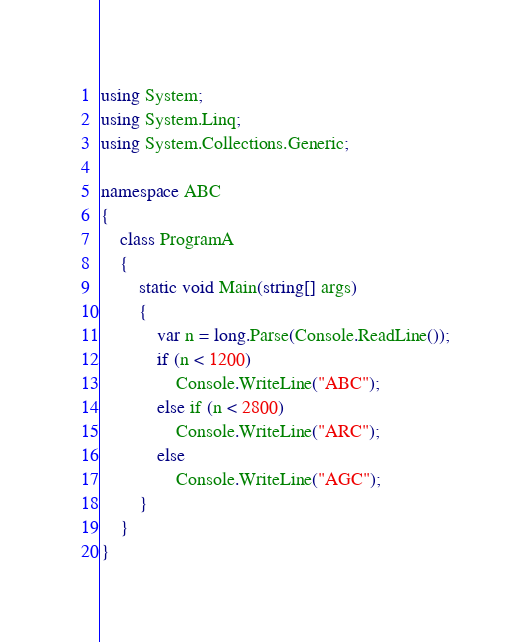<code> <loc_0><loc_0><loc_500><loc_500><_C#_>using System;
using System.Linq;
using System.Collections.Generic;

namespace ABC
{
    class ProgramA
    {
        static void Main(string[] args)
        {
            var n = long.Parse(Console.ReadLine());
            if (n < 1200)
                Console.WriteLine("ABC");
            else if (n < 2800)
                Console.WriteLine("ARC");
            else
                Console.WriteLine("AGC");
        }
    }
}
</code> 